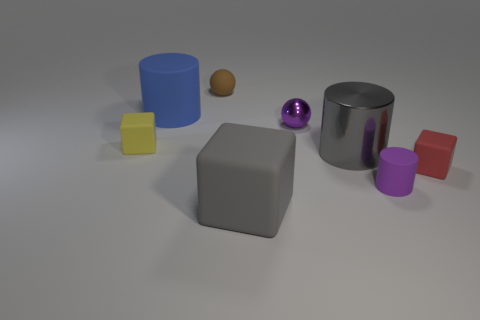There is a small rubber object behind the large blue matte object; what is its shape?
Your answer should be compact. Sphere. Is there anything else that has the same color as the big shiny thing?
Keep it short and to the point. Yes. Is the number of yellow matte objects on the right side of the tiny cylinder less than the number of tiny yellow rubber cubes?
Offer a terse response. Yes. How many rubber cylinders are the same size as the gray cube?
Your answer should be very brief. 1. The matte object that is the same color as the shiny sphere is what shape?
Offer a terse response. Cylinder. There is a small red matte thing that is to the right of the large thing that is on the left side of the matte block in front of the tiny purple rubber cylinder; what shape is it?
Your answer should be compact. Cube. The tiny cube that is to the left of the tiny red block is what color?
Your response must be concise. Yellow. How many things are purple objects that are in front of the red cube or things that are to the left of the big gray cube?
Your answer should be very brief. 4. How many big gray objects have the same shape as the yellow object?
Give a very brief answer. 1. There is another sphere that is the same size as the purple sphere; what color is it?
Offer a terse response. Brown. 